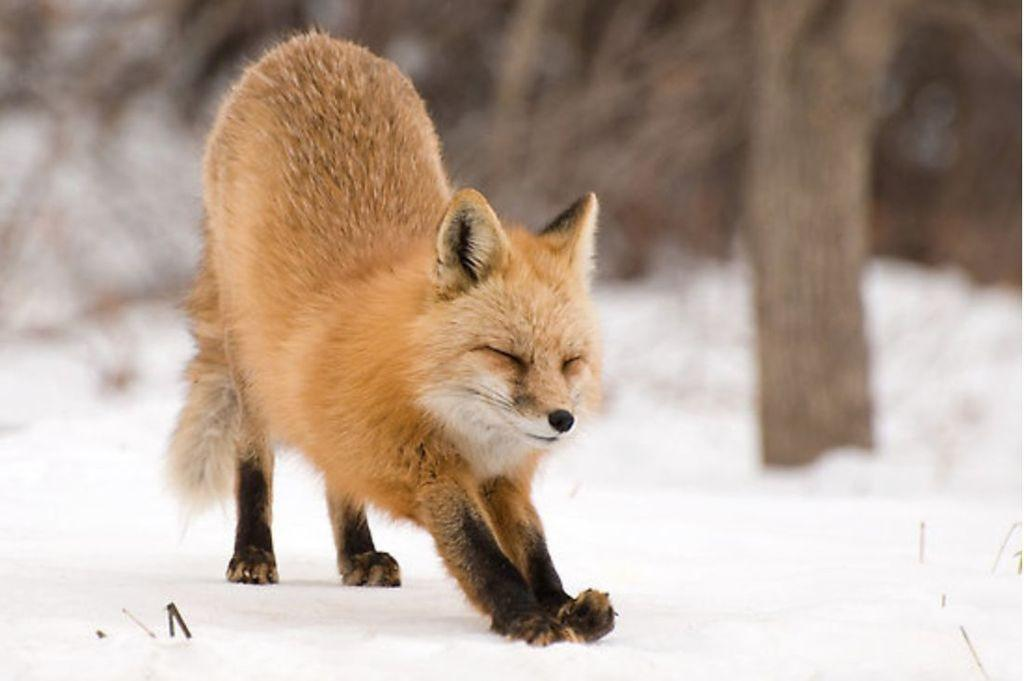What animal is present in the image? There is a fox in the image. What is the fox standing on? The fox is on the snow. What color is the fox? The fox is in brown color. What type of cup can be seen in the fox's paw in the image? There is no cup present in the image; the fox is standing on snow. 